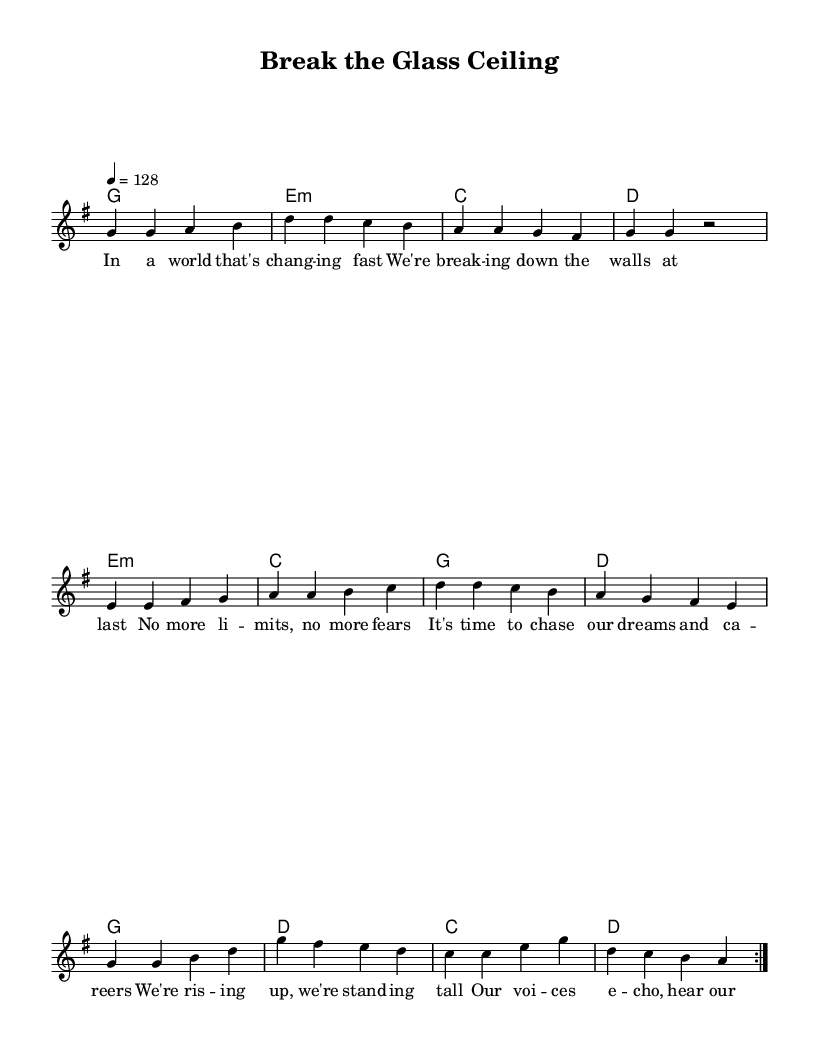What is the key signature of this music? The key signature indicates that this piece is in G major, which has one sharp (F#). You can identify the key signature at the beginning of the staff.
Answer: G major What is the time signature of this music? The time signature is found at the beginning of the staff; in this case, it is 4/4, indicating four beats per measure.
Answer: 4/4 What is the tempo marking for this music? The tempo marking indicates the speed of the piece, which is noted as 4 equals 128, meaning it should be played at a moderate pace of 128 beats per minute.
Answer: 128 How many times is the verse repeated? The score features a repeat symbol indicating that the verse section is intended to be played two times before moving on to the pre-chorus and chorus.
Answer: Two times What is the theme of the chorus? The chorus emphasizes themes of empowerment and breaking norms, encapsulated in the line "Break the glass ceiling, shatter the norm," indicating a focus on gender equality.
Answer: Empowerment Which chord follows the first measure of the verse? The first measure of the verse is accompanied by a G major chord, as indicated in the chord symbols below the staff.
Answer: G How does the pre-chorus connect to the chorus in terms of emotion? The pre-chorus builds emotional intensity with phrases like "We're rising up," smoothly transitioning into the powerful declaration of empowerment in the chorus, creating an effective climax.
Answer: Emotionally intense 